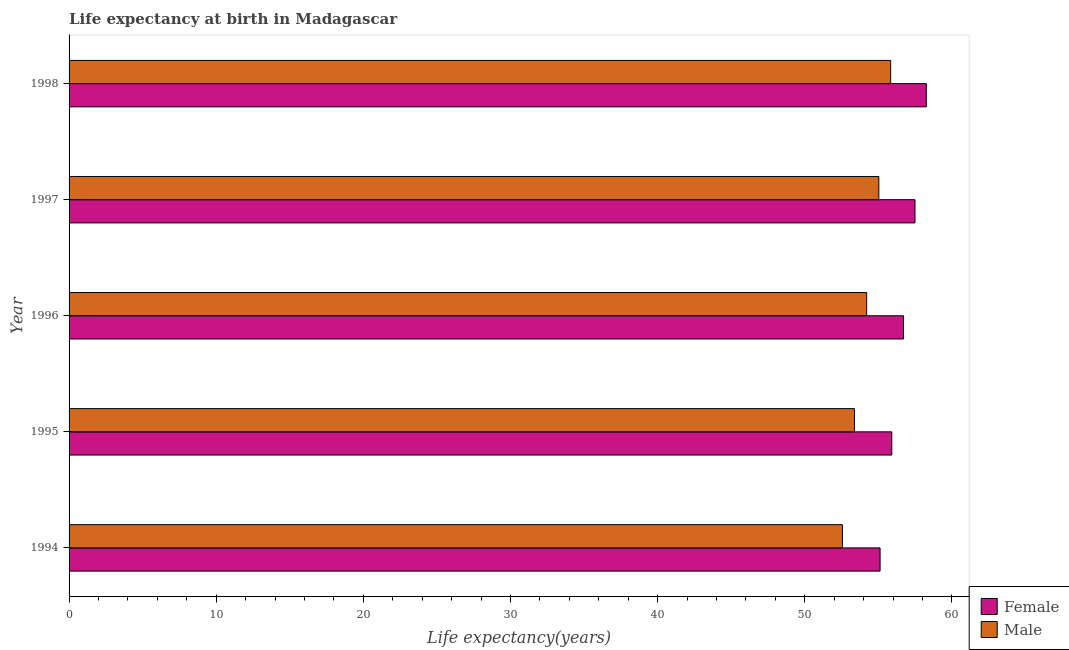Are the number of bars on each tick of the Y-axis equal?
Ensure brevity in your answer.  Yes. How many bars are there on the 5th tick from the bottom?
Ensure brevity in your answer.  2. What is the life expectancy(female) in 1994?
Provide a succinct answer. 55.12. Across all years, what is the maximum life expectancy(male)?
Ensure brevity in your answer.  55.84. Across all years, what is the minimum life expectancy(male)?
Give a very brief answer. 52.56. What is the total life expectancy(female) in the graph?
Provide a succinct answer. 283.5. What is the difference between the life expectancy(male) in 1995 and that in 1996?
Offer a very short reply. -0.83. What is the difference between the life expectancy(female) in 1994 and the life expectancy(male) in 1997?
Ensure brevity in your answer.  0.08. What is the average life expectancy(male) per year?
Offer a terse response. 54.2. In the year 1994, what is the difference between the life expectancy(female) and life expectancy(male)?
Your response must be concise. 2.56. In how many years, is the life expectancy(female) greater than 18 years?
Keep it short and to the point. 5. What is the ratio of the life expectancy(female) in 1994 to that in 1995?
Offer a terse response. 0.99. Is the life expectancy(male) in 1995 less than that in 1996?
Your response must be concise. Yes. What is the difference between the highest and the second highest life expectancy(female)?
Offer a terse response. 0.77. What is the difference between the highest and the lowest life expectancy(female)?
Keep it short and to the point. 3.14. In how many years, is the life expectancy(male) greater than the average life expectancy(male) taken over all years?
Keep it short and to the point. 3. Is the sum of the life expectancy(male) in 1996 and 1997 greater than the maximum life expectancy(female) across all years?
Your answer should be compact. Yes. What does the 2nd bar from the top in 1995 represents?
Your answer should be compact. Female. Are all the bars in the graph horizontal?
Make the answer very short. Yes. How many years are there in the graph?
Your answer should be very brief. 5. Does the graph contain any zero values?
Offer a very short reply. No. Does the graph contain grids?
Offer a terse response. No. Where does the legend appear in the graph?
Give a very brief answer. Bottom right. How many legend labels are there?
Provide a succinct answer. 2. How are the legend labels stacked?
Provide a succinct answer. Vertical. What is the title of the graph?
Provide a short and direct response. Life expectancy at birth in Madagascar. Does "Male labourers" appear as one of the legend labels in the graph?
Make the answer very short. No. What is the label or title of the X-axis?
Your answer should be compact. Life expectancy(years). What is the Life expectancy(years) of Female in 1994?
Offer a very short reply. 55.12. What is the Life expectancy(years) in Male in 1994?
Give a very brief answer. 52.56. What is the Life expectancy(years) of Female in 1995?
Your answer should be very brief. 55.91. What is the Life expectancy(years) in Male in 1995?
Provide a short and direct response. 53.38. What is the Life expectancy(years) in Female in 1996?
Your response must be concise. 56.71. What is the Life expectancy(years) in Male in 1996?
Your answer should be very brief. 54.21. What is the Life expectancy(years) in Female in 1997?
Provide a short and direct response. 57.49. What is the Life expectancy(years) in Male in 1997?
Your answer should be compact. 55.03. What is the Life expectancy(years) in Female in 1998?
Your response must be concise. 58.26. What is the Life expectancy(years) of Male in 1998?
Your response must be concise. 55.84. Across all years, what is the maximum Life expectancy(years) in Female?
Provide a short and direct response. 58.26. Across all years, what is the maximum Life expectancy(years) in Male?
Provide a succinct answer. 55.84. Across all years, what is the minimum Life expectancy(years) of Female?
Your answer should be compact. 55.12. Across all years, what is the minimum Life expectancy(years) in Male?
Provide a succinct answer. 52.56. What is the total Life expectancy(years) in Female in the graph?
Your answer should be compact. 283.5. What is the total Life expectancy(years) in Male in the graph?
Offer a very short reply. 271.01. What is the difference between the Life expectancy(years) of Female in 1994 and that in 1995?
Offer a very short reply. -0.8. What is the difference between the Life expectancy(years) of Male in 1994 and that in 1995?
Give a very brief answer. -0.82. What is the difference between the Life expectancy(years) of Female in 1994 and that in 1996?
Make the answer very short. -1.59. What is the difference between the Life expectancy(years) of Male in 1994 and that in 1996?
Your response must be concise. -1.65. What is the difference between the Life expectancy(years) of Female in 1994 and that in 1997?
Provide a succinct answer. -2.38. What is the difference between the Life expectancy(years) in Male in 1994 and that in 1997?
Keep it short and to the point. -2.48. What is the difference between the Life expectancy(years) of Female in 1994 and that in 1998?
Ensure brevity in your answer.  -3.14. What is the difference between the Life expectancy(years) in Male in 1994 and that in 1998?
Make the answer very short. -3.28. What is the difference between the Life expectancy(years) of Female in 1995 and that in 1996?
Offer a terse response. -0.79. What is the difference between the Life expectancy(years) of Male in 1995 and that in 1996?
Make the answer very short. -0.83. What is the difference between the Life expectancy(years) in Female in 1995 and that in 1997?
Your answer should be very brief. -1.58. What is the difference between the Life expectancy(years) of Male in 1995 and that in 1997?
Offer a terse response. -1.66. What is the difference between the Life expectancy(years) in Female in 1995 and that in 1998?
Provide a succinct answer. -2.35. What is the difference between the Life expectancy(years) of Male in 1995 and that in 1998?
Ensure brevity in your answer.  -2.46. What is the difference between the Life expectancy(years) of Female in 1996 and that in 1997?
Offer a terse response. -0.79. What is the difference between the Life expectancy(years) in Male in 1996 and that in 1997?
Keep it short and to the point. -0.83. What is the difference between the Life expectancy(years) of Female in 1996 and that in 1998?
Ensure brevity in your answer.  -1.55. What is the difference between the Life expectancy(years) of Male in 1996 and that in 1998?
Your answer should be compact. -1.63. What is the difference between the Life expectancy(years) of Female in 1997 and that in 1998?
Keep it short and to the point. -0.77. What is the difference between the Life expectancy(years) of Male in 1997 and that in 1998?
Your answer should be very brief. -0.8. What is the difference between the Life expectancy(years) in Female in 1994 and the Life expectancy(years) in Male in 1995?
Offer a terse response. 1.74. What is the difference between the Life expectancy(years) in Female in 1994 and the Life expectancy(years) in Male in 1996?
Make the answer very short. 0.91. What is the difference between the Life expectancy(years) of Female in 1994 and the Life expectancy(years) of Male in 1997?
Offer a very short reply. 0.08. What is the difference between the Life expectancy(years) of Female in 1994 and the Life expectancy(years) of Male in 1998?
Keep it short and to the point. -0.72. What is the difference between the Life expectancy(years) of Female in 1995 and the Life expectancy(years) of Male in 1996?
Give a very brief answer. 1.71. What is the difference between the Life expectancy(years) in Female in 1995 and the Life expectancy(years) in Male in 1997?
Your response must be concise. 0.88. What is the difference between the Life expectancy(years) in Female in 1995 and the Life expectancy(years) in Male in 1998?
Your response must be concise. 0.08. What is the difference between the Life expectancy(years) in Female in 1996 and the Life expectancy(years) in Male in 1997?
Offer a very short reply. 1.67. What is the difference between the Life expectancy(years) in Female in 1996 and the Life expectancy(years) in Male in 1998?
Give a very brief answer. 0.87. What is the difference between the Life expectancy(years) of Female in 1997 and the Life expectancy(years) of Male in 1998?
Your response must be concise. 1.66. What is the average Life expectancy(years) of Female per year?
Your answer should be compact. 56.7. What is the average Life expectancy(years) of Male per year?
Provide a succinct answer. 54.2. In the year 1994, what is the difference between the Life expectancy(years) of Female and Life expectancy(years) of Male?
Ensure brevity in your answer.  2.56. In the year 1995, what is the difference between the Life expectancy(years) in Female and Life expectancy(years) in Male?
Make the answer very short. 2.54. In the year 1996, what is the difference between the Life expectancy(years) in Female and Life expectancy(years) in Male?
Make the answer very short. 2.5. In the year 1997, what is the difference between the Life expectancy(years) of Female and Life expectancy(years) of Male?
Provide a succinct answer. 2.46. In the year 1998, what is the difference between the Life expectancy(years) in Female and Life expectancy(years) in Male?
Offer a very short reply. 2.42. What is the ratio of the Life expectancy(years) in Female in 1994 to that in 1995?
Offer a very short reply. 0.99. What is the ratio of the Life expectancy(years) of Male in 1994 to that in 1995?
Provide a short and direct response. 0.98. What is the ratio of the Life expectancy(years) of Male in 1994 to that in 1996?
Make the answer very short. 0.97. What is the ratio of the Life expectancy(years) in Female in 1994 to that in 1997?
Your answer should be compact. 0.96. What is the ratio of the Life expectancy(years) of Male in 1994 to that in 1997?
Offer a very short reply. 0.95. What is the ratio of the Life expectancy(years) in Female in 1994 to that in 1998?
Provide a succinct answer. 0.95. What is the ratio of the Life expectancy(years) of Male in 1994 to that in 1998?
Keep it short and to the point. 0.94. What is the ratio of the Life expectancy(years) of Female in 1995 to that in 1996?
Offer a terse response. 0.99. What is the ratio of the Life expectancy(years) in Male in 1995 to that in 1996?
Make the answer very short. 0.98. What is the ratio of the Life expectancy(years) in Female in 1995 to that in 1997?
Make the answer very short. 0.97. What is the ratio of the Life expectancy(years) of Male in 1995 to that in 1997?
Provide a succinct answer. 0.97. What is the ratio of the Life expectancy(years) in Female in 1995 to that in 1998?
Provide a succinct answer. 0.96. What is the ratio of the Life expectancy(years) of Male in 1995 to that in 1998?
Give a very brief answer. 0.96. What is the ratio of the Life expectancy(years) of Female in 1996 to that in 1997?
Give a very brief answer. 0.99. What is the ratio of the Life expectancy(years) of Male in 1996 to that in 1997?
Ensure brevity in your answer.  0.98. What is the ratio of the Life expectancy(years) in Female in 1996 to that in 1998?
Make the answer very short. 0.97. What is the ratio of the Life expectancy(years) of Male in 1996 to that in 1998?
Ensure brevity in your answer.  0.97. What is the ratio of the Life expectancy(years) of Female in 1997 to that in 1998?
Offer a very short reply. 0.99. What is the ratio of the Life expectancy(years) of Male in 1997 to that in 1998?
Give a very brief answer. 0.99. What is the difference between the highest and the second highest Life expectancy(years) in Female?
Provide a short and direct response. 0.77. What is the difference between the highest and the second highest Life expectancy(years) in Male?
Provide a succinct answer. 0.8. What is the difference between the highest and the lowest Life expectancy(years) of Female?
Make the answer very short. 3.14. What is the difference between the highest and the lowest Life expectancy(years) in Male?
Ensure brevity in your answer.  3.28. 